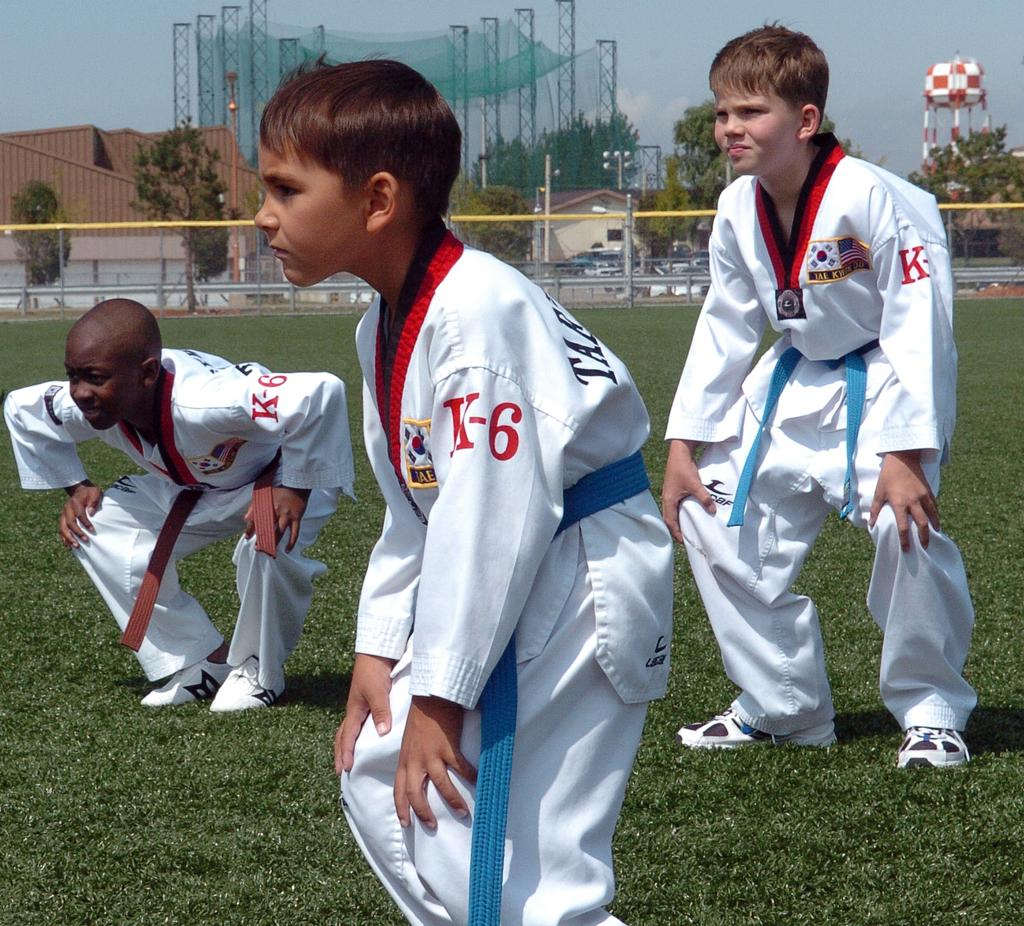<image>
Create a compact narrative representing the image presented. Three young boys in a field are wearing karate uniforms that say K-6. 